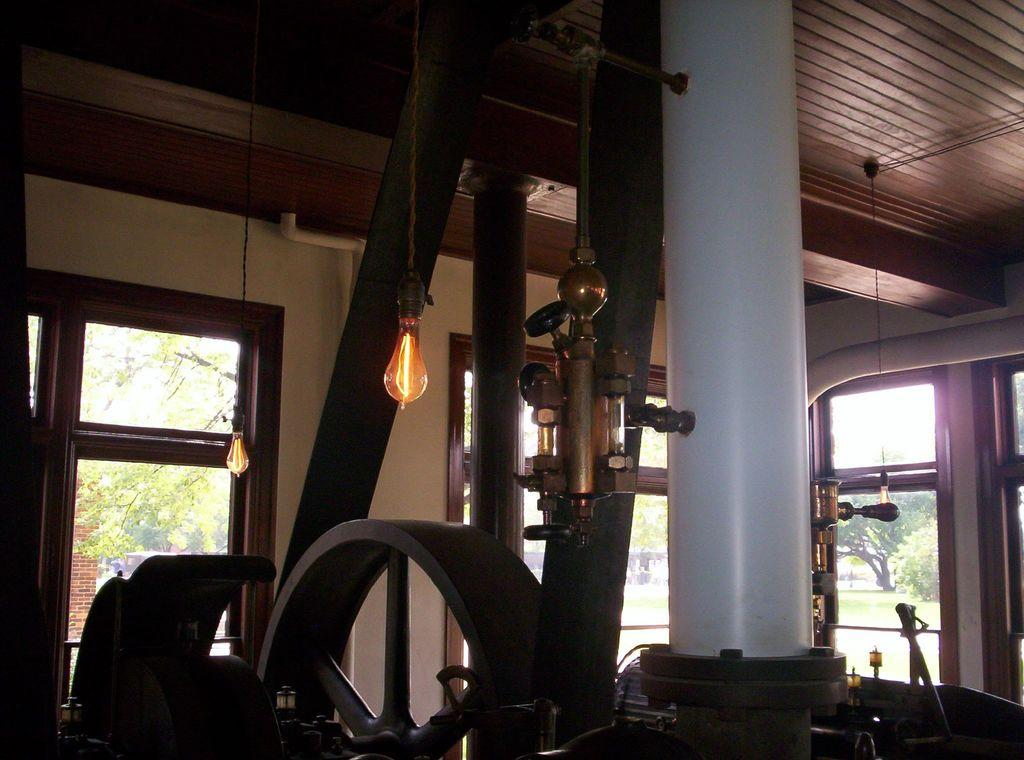What is the main object in the image? There is a machine in the image. What is located above the machine? There are two bulbs above the machine. What type of doors are beside the machine? There are glass doors beside the machine. What can be seen in the background of the image? There are trees in the background of the image. What role does the father play in the committee meeting depicted in the image? There is no father or committee meeting present in the image. 